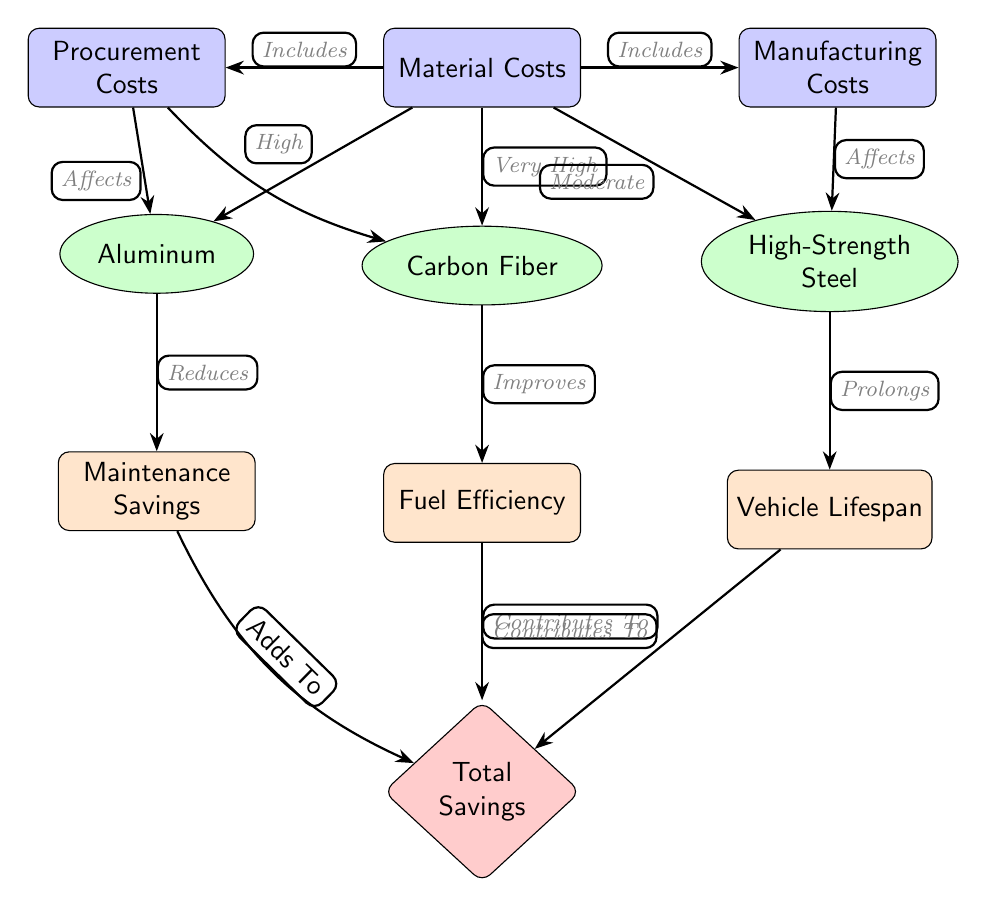What are the three types of materials represented in this diagram? The diagram shows three types of materials located below the "Material Costs" node: Aluminum, Carbon Fiber, and High-Strength Steel. These nodes are distinct and each represents a type of lightweight material in automotive design.
Answer: Aluminum, Carbon Fiber, High-Strength Steel What is the relationship between Carbon Fiber and Fuel Efficiency? In the diagram, there is a directed edge from the Carbon Fiber node to the Fuel Efficiency node, labeled "Improves." This indicates that the use of Carbon Fiber has a positive impact on fuel efficiency in vehicles.
Answer: Improves How many nodes are related to vehicle savings in this diagram? The diagram contains three nodes related to savings: Maintenance Savings, Fuel Efficiency, and Vehicle Lifespan. Each of these nodes contributes to the overall savings in vehicle operation and maintenance.
Answer: Three What type of cost is associated with High-Strength Steel? The Manufacturing Costs node has a directed edge labeled "Affects" going into the High-Strength Steel node. This indicates that Manufacturing Costs are relevant to High-Strength Steel, affecting its overall cost consideration in the automotive context.
Answer: Manufacturing Costs What do Maintenance Savings, Fuel Efficiency, and Vehicle Lifespan collectively contribute to? The arrows originating from the nodes Maintenance Savings, Fuel Efficiency, and Vehicle Lifespan point towards the Total Savings node, indicating that they each contribute to the overall savings seen in vehicle performance and operational costs.
Answer: Total Savings Which material has the highest cost associated in the diagram? The diagram directly associates "Very High" with the Carbon Fiber node in connection to Material Costs, indicating it has the highest cost among the materials presented.
Answer: Very High What effect does Aluminum have on Maintenance Savings? The edge from the Aluminum node to the Maintenance Savings node is labeled "Reduces," indicating that using Aluminum material leads to a reduction in maintenance costs over time.
Answer: Reduces What node is affected by both Procurement Costs and Manufacturing Costs? The Material Costs node shows directed edges toward Procurement Costs and Manufacturing Costs, thus indicating that both types of costs affect the Material Costs associated with automotive parts.
Answer: Material Costs 